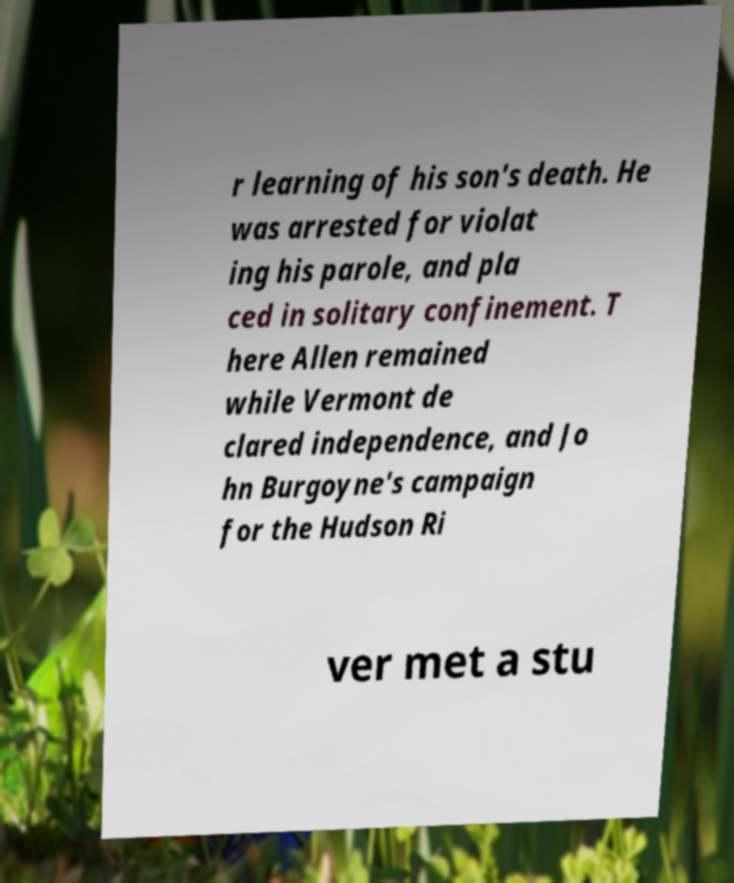Please read and relay the text visible in this image. What does it say? r learning of his son's death. He was arrested for violat ing his parole, and pla ced in solitary confinement. T here Allen remained while Vermont de clared independence, and Jo hn Burgoyne's campaign for the Hudson Ri ver met a stu 